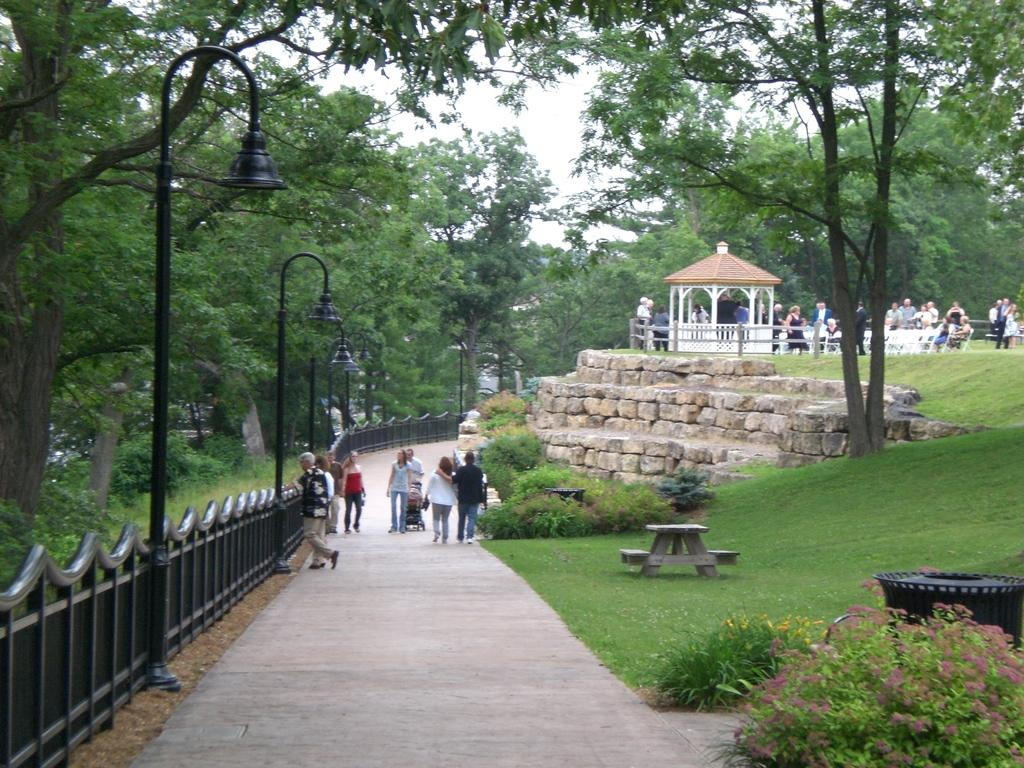How many people can be seen in the image? There are people in the image, but the exact number is not specified. What type of surface can be seen under the people's feet? There is ground with some objects in the image. What structures are present in the image? There are poles, fencing, a shed, and lights in the image. What type of vegetation is visible in the image? There are trees, grass, and plants in the image. What is the background of the image? The sky is visible in the image. How many leaves are on the umbrella in the image? There is no umbrella present in the image. How many spiders are crawling on the shed in the image? There is no mention of spiders in the image; it only states that there is a shed present. 